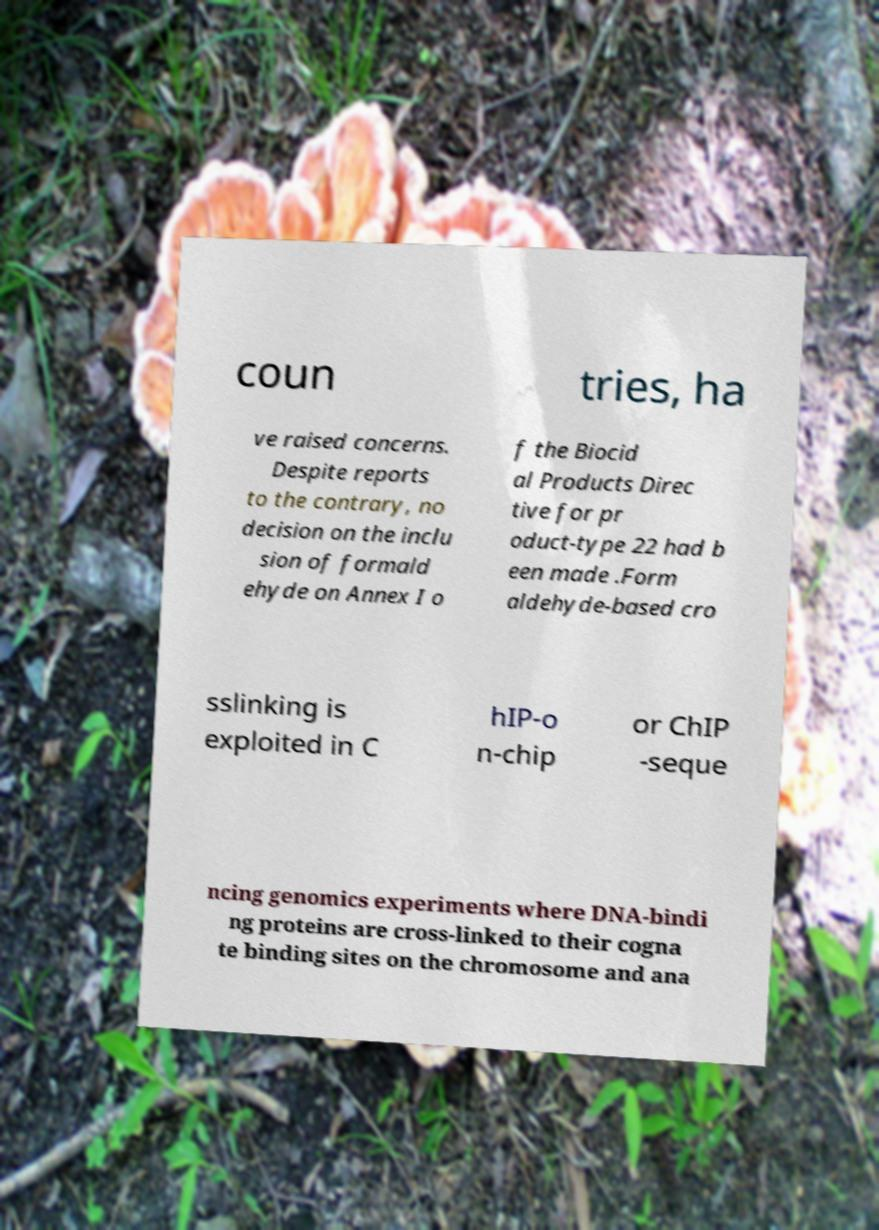I need the written content from this picture converted into text. Can you do that? coun tries, ha ve raised concerns. Despite reports to the contrary, no decision on the inclu sion of formald ehyde on Annex I o f the Biocid al Products Direc tive for pr oduct-type 22 had b een made .Form aldehyde-based cro sslinking is exploited in C hIP-o n-chip or ChIP -seque ncing genomics experiments where DNA-bindi ng proteins are cross-linked to their cogna te binding sites on the chromosome and ana 